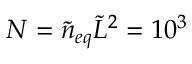<formula> <loc_0><loc_0><loc_500><loc_500>N = \tilde { n } _ { e q } \tilde { L } ^ { 2 } = 1 0 ^ { 3 }</formula> 